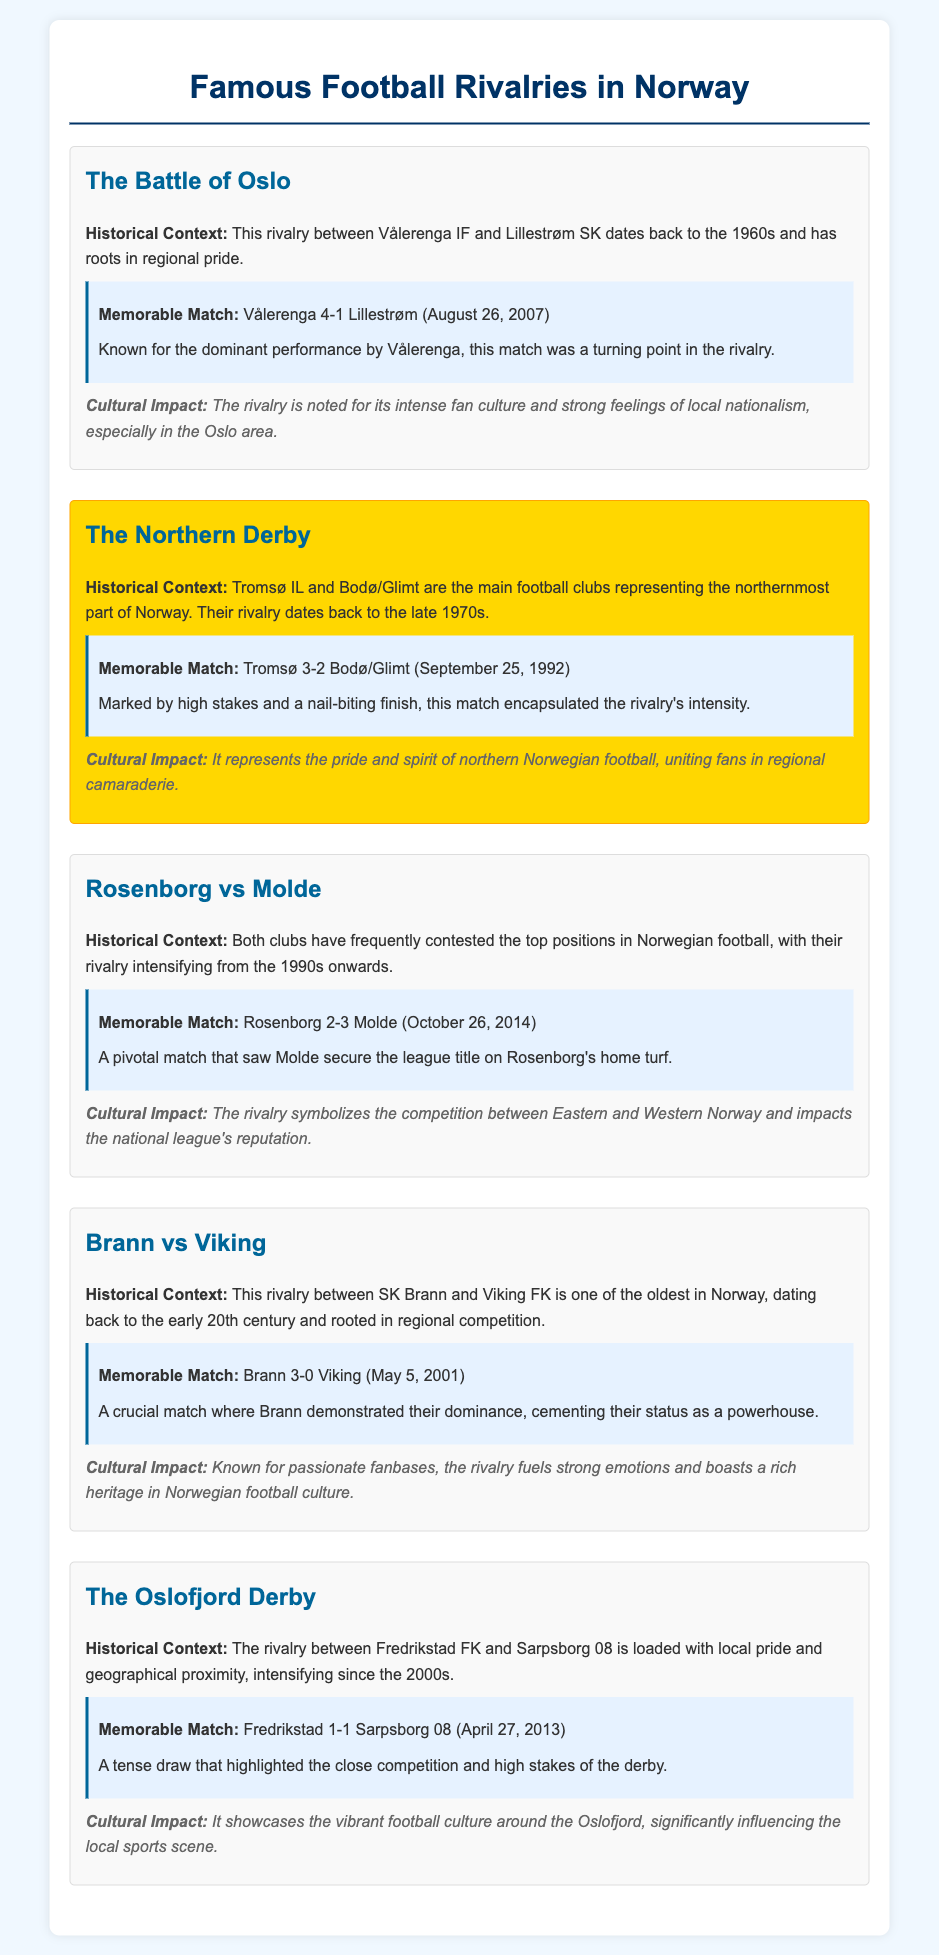What is the historical context of The Battle of Oslo? The historical context highlights the rivalry between Vålerenga IF and Lillestrøm SK dating back to the 1960s and has roots in regional pride.
Answer: 1960s Which clubs are involved in The Northern Derby? The Northern Derby features Tromsø IL and Bodø/Glimt representing northern Norway.
Answer: Tromsø IL and Bodø/Glimt When did Tromsø beat Bodø/Glimt in a memorable match? The memorable match where Tromsø defeated Bodø/Glimt was on September 25, 1992.
Answer: September 25, 1992 What was the result of the memorable match between Rosenborg and Molde on October 26, 2014? The match result was Rosenborg 2-3 Molde, a pivotal match for the league title.
Answer: 2-3 Molde What is the cultural impact of the Brann vs Viking rivalry? The cultural impact includes strong emotions and a rich heritage in Norwegian football culture.
Answer: Strong emotions and rich heritage How does the Oslofjord Derby reflect local pride? The rivalry is loaded with local pride and geographical proximity, intensifying since the 2000s.
Answer: Local pride and geographical proximity In what year did the rivalry between SK Brann and Viking FK begin? The rivalry dates back to the early 20th century, indicating its long-standing nature.
Answer: Early 20th century What was a significant moment in the rivalry between Vålerenga and Lillestrøm? A significant moment was the dominant performance by Vålerenga in the match on August 26, 2007.
Answer: August 26, 2007 What does the Northern Derby represent in terms of regional identity? It represents the pride and spirit of northern Norwegian football among its fans.
Answer: Pride and spirit of northern Norwegian football 